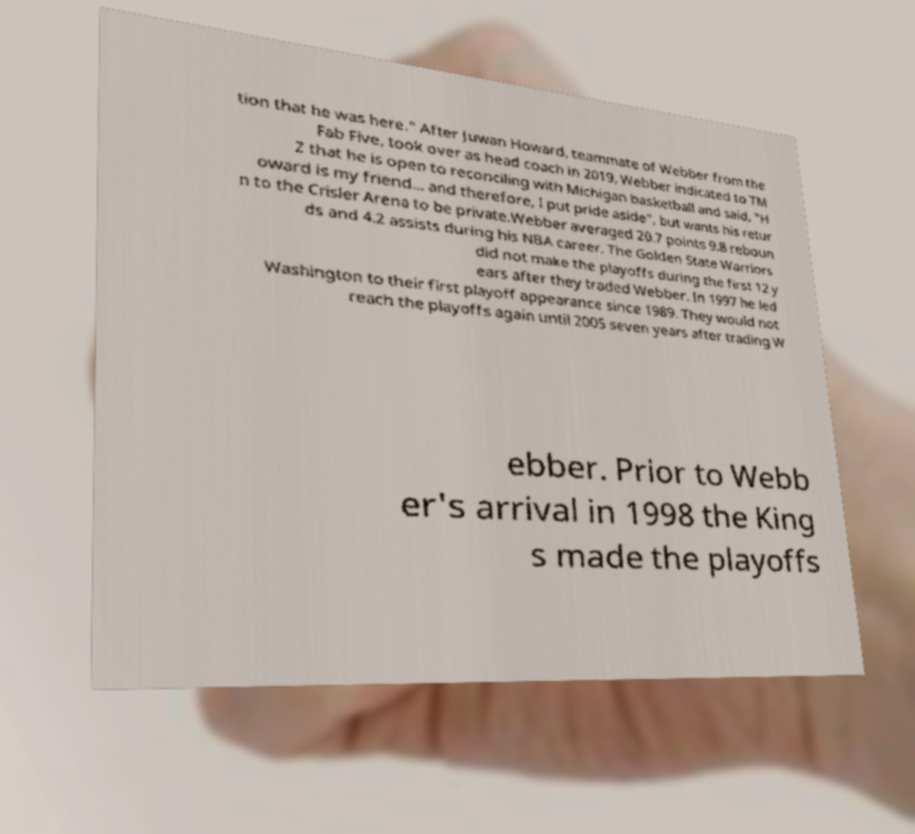Please identify and transcribe the text found in this image. tion that he was here." After Juwan Howard, teammate of Webber from the Fab Five, took over as head coach in 2019, Webber indicated to TM Z that he is open to reconciling with Michigan basketball and said, "H oward is my friend... and therefore, I put pride aside", but wants his retur n to the Crisler Arena to be private.Webber averaged 20.7 points 9.8 reboun ds and 4.2 assists during his NBA career. The Golden State Warriors did not make the playoffs during the first 12 y ears after they traded Webber. In 1997 he led Washington to their first playoff appearance since 1989. They would not reach the playoffs again until 2005 seven years after trading W ebber. Prior to Webb er's arrival in 1998 the King s made the playoffs 